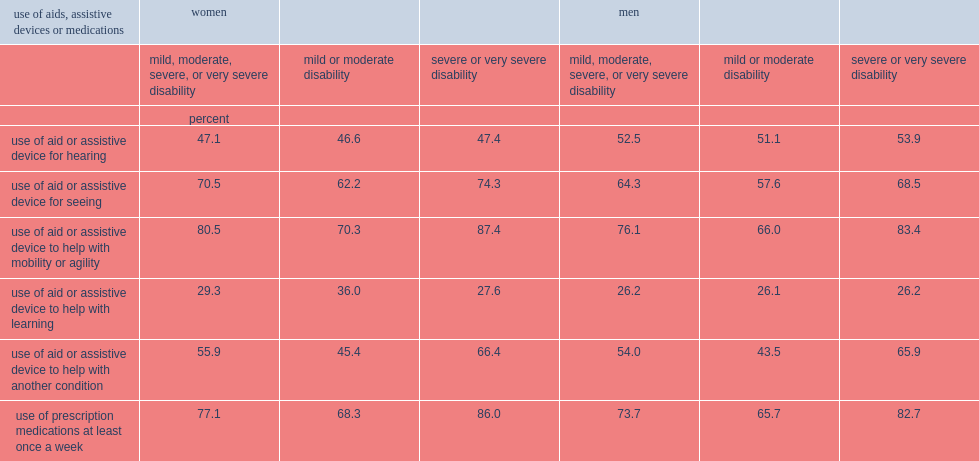Who were more likely to report using prescription medications at least once a week, women with disabilities or men with disabilities? Women. How many percentage point of women with severe or very severe disabilities used of prescribed medications at least once a week? 86.0. How many percentage point of women with disabilities aged 15 or older reported using mobility or agility-related aids or assistive devices? 80.5. Who wre more likely to reporte using mobility or agility-related aids or assistive devices and assistive devices, women with mild or moderate disabilities or women with severe or very severe disabilities? Severe or very severe disability. Who wre more likely to reporte using mobility or agility-related aids or assistive devices and assistive devices, women with severe or very severe disabilities or men with severe or very severe disabilities? Women. 